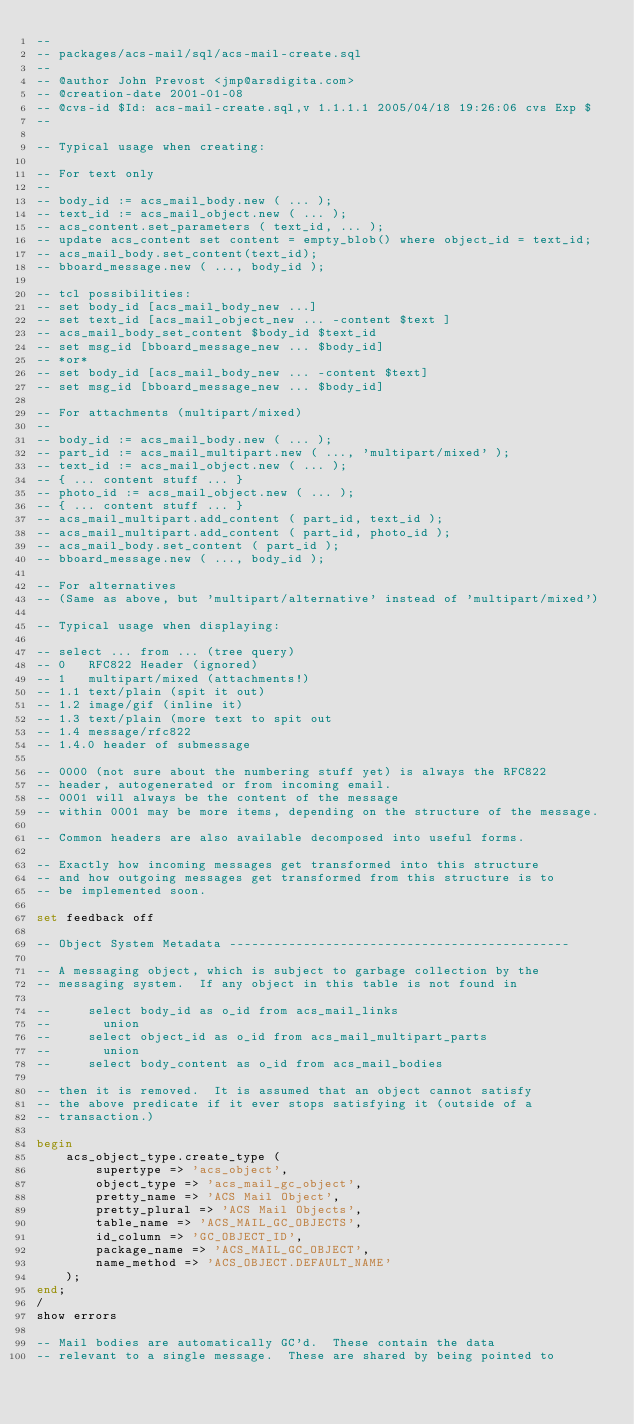Convert code to text. <code><loc_0><loc_0><loc_500><loc_500><_SQL_>--
-- packages/acs-mail/sql/acs-mail-create.sql
--
-- @author John Prevost <jmp@arsdigita.com>
-- @creation-date 2001-01-08
-- @cvs-id $Id: acs-mail-create.sql,v 1.1.1.1 2005/04/18 19:26:06 cvs Exp $
--

-- Typical usage when creating:

-- For text only
--
-- body_id := acs_mail_body.new ( ... );
-- text_id := acs_mail_object.new ( ... );
-- acs_content.set_parameters ( text_id, ... );
-- update acs_content set content = empty_blob() where object_id = text_id;
-- acs_mail_body.set_content(text_id);
-- bboard_message.new ( ..., body_id );

-- tcl possibilities:
-- set body_id [acs_mail_body_new ...]
-- set text_id [acs_mail_object_new ... -content $text ]
-- acs_mail_body_set_content $body_id $text_id
-- set msg_id [bboard_message_new ... $body_id]
-- *or*
-- set body_id [acs_mail_body_new ... -content $text]
-- set msg_id [bboard_message_new ... $body_id]

-- For attachments (multipart/mixed)
--
-- body_id := acs_mail_body.new ( ... );
-- part_id := acs_mail_multipart.new ( ..., 'multipart/mixed' );
-- text_id := acs_mail_object.new ( ... );
-- { ... content stuff ... }
-- photo_id := acs_mail_object.new ( ... );
-- { ... content stuff ... }
-- acs_mail_multipart.add_content ( part_id, text_id );
-- acs_mail_multipart.add_content ( part_id, photo_id );
-- acs_mail_body.set_content ( part_id );
-- bboard_message.new ( ..., body_id );

-- For alternatives
-- (Same as above, but 'multipart/alternative' instead of 'multipart/mixed')

-- Typical usage when displaying:

-- select ... from ... (tree query)
-- 0   RFC822 Header (ignored)
-- 1   multipart/mixed (attachments!)
-- 1.1 text/plain (spit it out)
-- 1.2 image/gif (inline it)
-- 1.3 text/plain (more text to spit out
-- 1.4 message/rfc822
-- 1.4.0 header of submessage

-- 0000 (not sure about the numbering stuff yet) is always the RFC822
-- header, autogenerated or from incoming email.
-- 0001 will always be the content of the message
-- within 0001 may be more items, depending on the structure of the message.

-- Common headers are also available decomposed into useful forms.

-- Exactly how incoming messages get transformed into this structure
-- and how outgoing messages get transformed from this structure is to
-- be implemented soon.

set feedback off

-- Object System Metadata ----------------------------------------------

-- A messaging object, which is subject to garbage collection by the
-- messaging system.  If any object in this table is not found in

--     select body_id as o_id from acs_mail_links
--       union
--     select object_id as o_id from acs_mail_multipart_parts
--       union
--     select body_content as o_id from acs_mail_bodies

-- then it is removed.  It is assumed that an object cannot satisfy
-- the above predicate if it ever stops satisfying it (outside of a
-- transaction.)

begin
    acs_object_type.create_type (
        supertype => 'acs_object',
        object_type => 'acs_mail_gc_object',
        pretty_name => 'ACS Mail Object',
        pretty_plural => 'ACS Mail Objects',
        table_name => 'ACS_MAIL_GC_OBJECTS',
        id_column => 'GC_OBJECT_ID',
        package_name => 'ACS_MAIL_GC_OBJECT',
        name_method => 'ACS_OBJECT.DEFAULT_NAME'
    );
end;
/
show errors

-- Mail bodies are automatically GC'd.  These contain the data
-- relevant to a single message.  These are shared by being pointed to</code> 